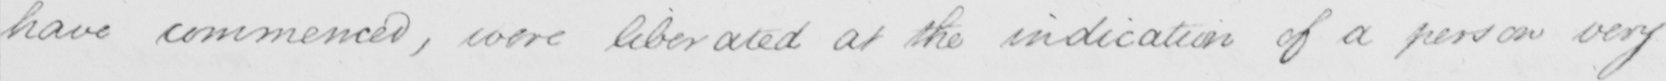What does this handwritten line say? have commenced , were liberated at the indication of a person very 